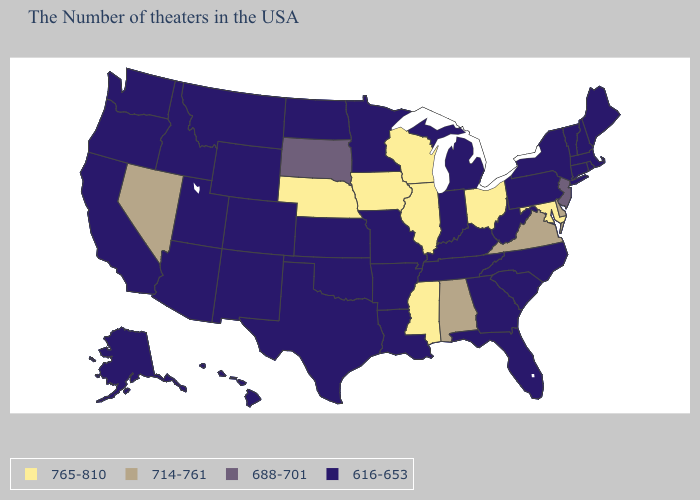What is the highest value in the MidWest ?
Give a very brief answer. 765-810. Does Virginia have the lowest value in the USA?
Short answer required. No. Among the states that border Louisiana , does Arkansas have the lowest value?
Write a very short answer. Yes. Is the legend a continuous bar?
Quick response, please. No. Does the first symbol in the legend represent the smallest category?
Short answer required. No. Does the map have missing data?
Be succinct. No. What is the lowest value in states that border Arizona?
Quick response, please. 616-653. Name the states that have a value in the range 616-653?
Answer briefly. Maine, Massachusetts, Rhode Island, New Hampshire, Vermont, Connecticut, New York, Pennsylvania, North Carolina, South Carolina, West Virginia, Florida, Georgia, Michigan, Kentucky, Indiana, Tennessee, Louisiana, Missouri, Arkansas, Minnesota, Kansas, Oklahoma, Texas, North Dakota, Wyoming, Colorado, New Mexico, Utah, Montana, Arizona, Idaho, California, Washington, Oregon, Alaska, Hawaii. Name the states that have a value in the range 765-810?
Concise answer only. Maryland, Ohio, Wisconsin, Illinois, Mississippi, Iowa, Nebraska. Does Pennsylvania have a lower value than Wisconsin?
Answer briefly. Yes. Which states have the lowest value in the USA?
Be succinct. Maine, Massachusetts, Rhode Island, New Hampshire, Vermont, Connecticut, New York, Pennsylvania, North Carolina, South Carolina, West Virginia, Florida, Georgia, Michigan, Kentucky, Indiana, Tennessee, Louisiana, Missouri, Arkansas, Minnesota, Kansas, Oklahoma, Texas, North Dakota, Wyoming, Colorado, New Mexico, Utah, Montana, Arizona, Idaho, California, Washington, Oregon, Alaska, Hawaii. What is the value of Idaho?
Give a very brief answer. 616-653. Name the states that have a value in the range 688-701?
Answer briefly. New Jersey, South Dakota. Name the states that have a value in the range 765-810?
Keep it brief. Maryland, Ohio, Wisconsin, Illinois, Mississippi, Iowa, Nebraska. Name the states that have a value in the range 765-810?
Keep it brief. Maryland, Ohio, Wisconsin, Illinois, Mississippi, Iowa, Nebraska. 